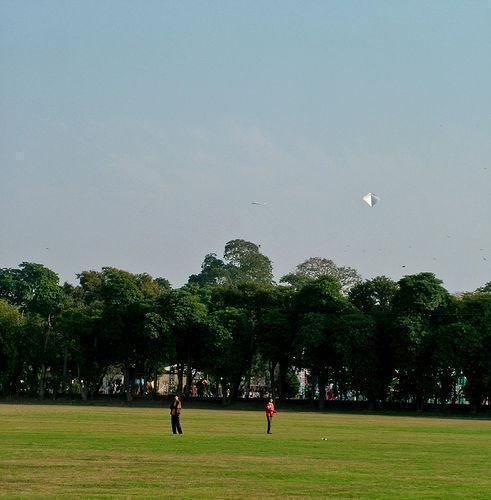What is the best shape for a kite?
Pick the correct solution from the four options below to address the question.
Options: Square, triangular, rectangle, diamond. Diamond. 